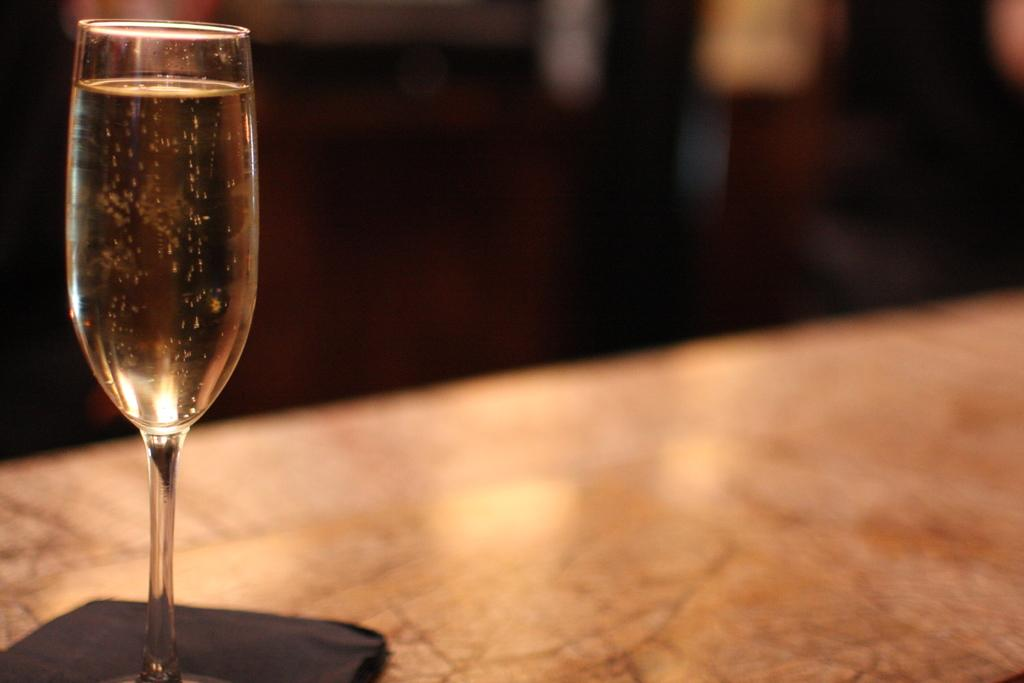What is present on the left side of the image? There is a wine glass on the left side of the image. Can you describe the wine glass in more detail? Unfortunately, the provided facts do not offer any additional details about the wine glass. What type of yarn is being used to create a record of the temper in the image? There is no yarn, record, or temper present in the image. 